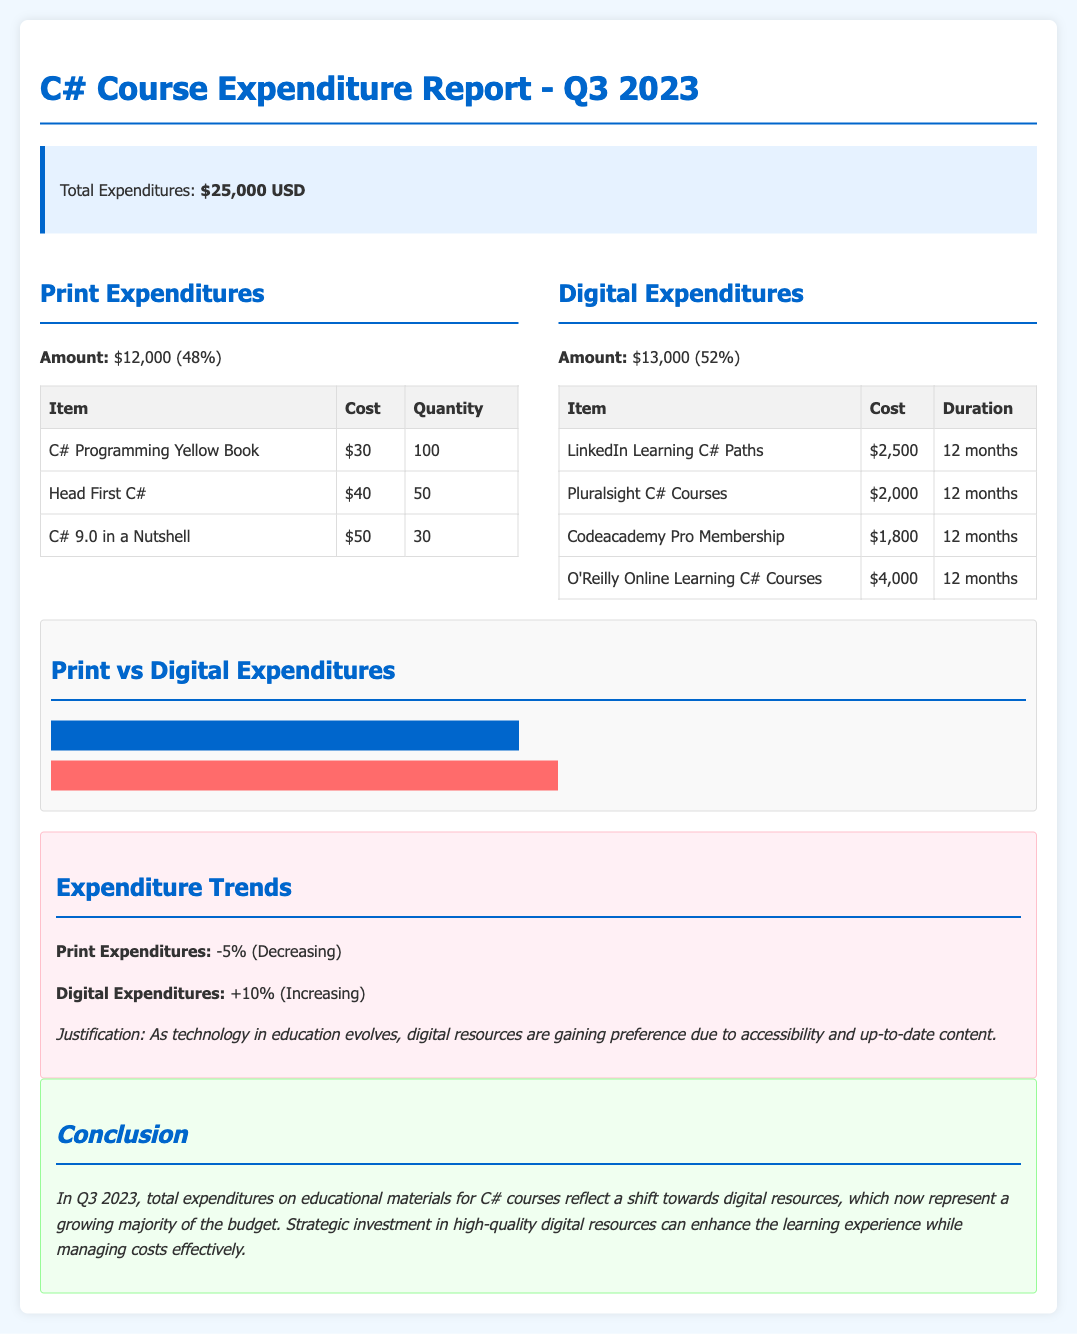What is the total expenditure for Q3 2023? The total expenditure is stated in the summary section, specifically under total expenditures.
Answer: $25,000 USD What percentage of expenditures is allocated to digital resources? The digital expenditures percentage is provided alongside the amount in the expenditure breakdown.
Answer: 52% How much was spent on the "C# Programming Yellow Book"? The cost of the "C# Programming Yellow Book" is listed in the print expenditures table.
Answer: $30 What is the trend for digital expenditures? The trends section specifies the change in digital expenditures over the last quarter.
Answer: +10% (Increasing) Which item had the highest cost in digital expenditures? The digital expenditures table includes costs for each item, allowing for an easy comparison.
Answer: O'Reilly Online Learning C# Courses ($4,000) What is the total amount spent on print resources? The amount for print expenditures is explicitly mentioned in the breakdown section of the document.
Answer: $12,000 What justification is provided for the shift towards digital resources? The justification for changing expenditure trends is mentioned in the trends section.
Answer: Accessibility and up-to-date content How many copies of "Head First C#" were purchased? The quantity of "Head First C#" can be found in the print expenditures table.
Answer: 50 What color represents digital expenditures in the chart? The chart shows expenditures with different colors, and this can be inferred from the chart bar.
Answer: Pink (or #ff6b6b) 